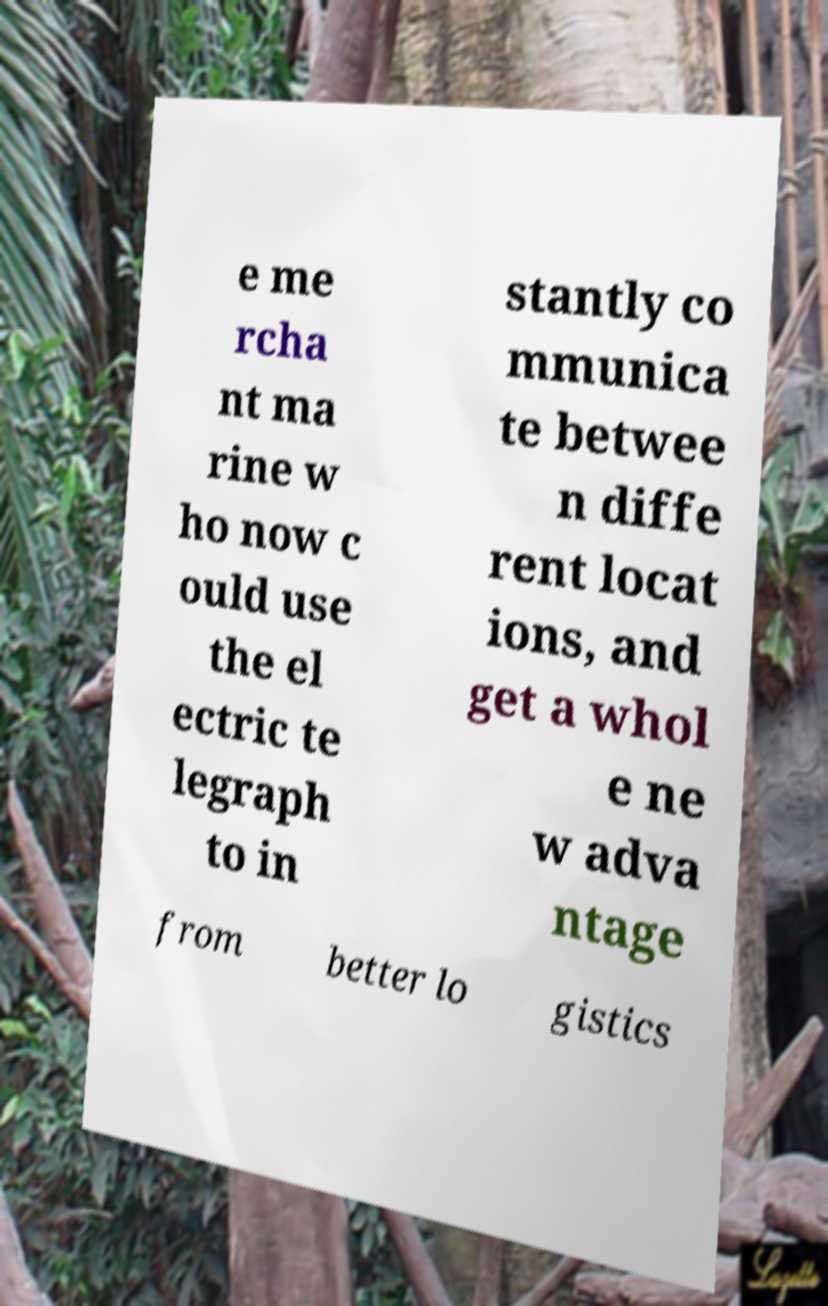I need the written content from this picture converted into text. Can you do that? e me rcha nt ma rine w ho now c ould use the el ectric te legraph to in stantly co mmunica te betwee n diffe rent locat ions, and get a whol e ne w adva ntage from better lo gistics 